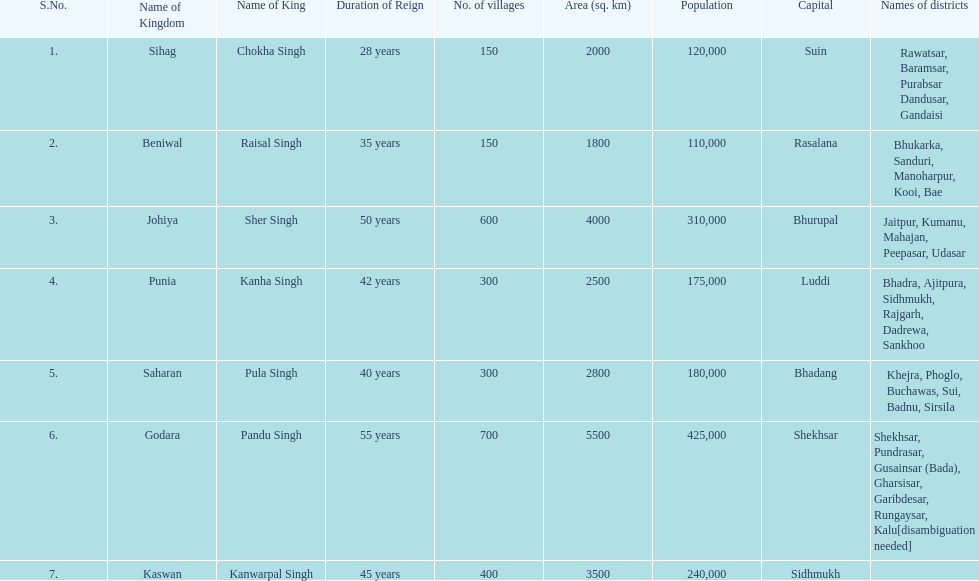What was the total number of districts within the state of godara? 7. 